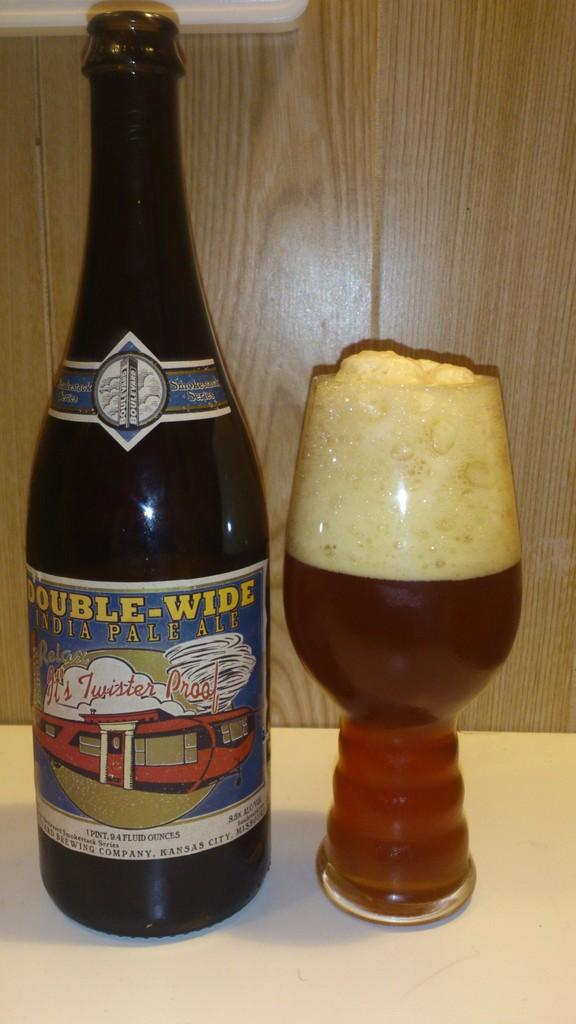<image>
Create a compact narrative representing the image presented. A full mug of beer is sitting beside a bottle of Double Wide beer 